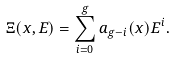<formula> <loc_0><loc_0><loc_500><loc_500>\Xi ( x , E ) = \sum _ { i = 0 } ^ { g } a _ { g - i } ( x ) E ^ { i } .</formula> 